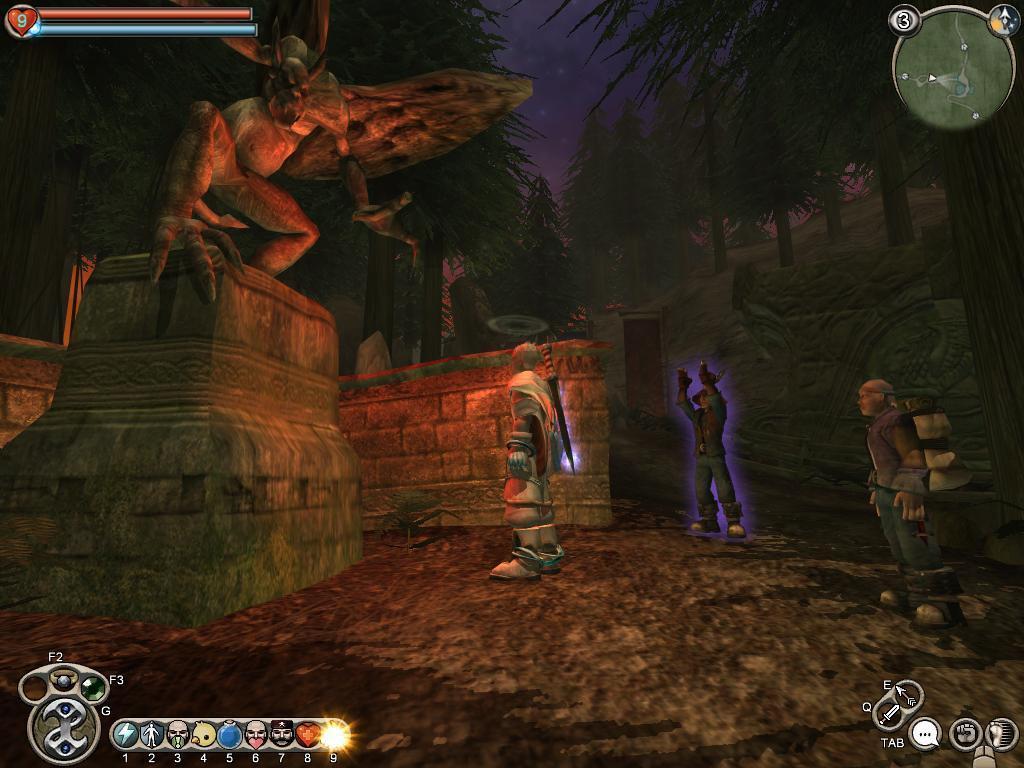Could you give a brief overview of what you see in this image? This is an animation picture. On the left side there is a sculpture on a wall. Also some people are there. On the corners there are some icons. In the back there are trees. 